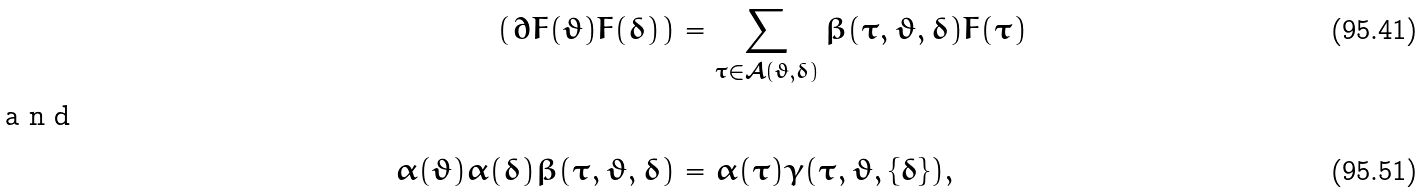Convert formula to latex. <formula><loc_0><loc_0><loc_500><loc_500>\left ( \partial F ( \vartheta ) F ( \delta ) \right ) & = \sum _ { \tau \in \mathcal { A } ( \vartheta , \delta ) } \beta ( \tau , \vartheta , \delta ) F ( \tau ) \\ \intertext { a n d } \alpha ( \vartheta ) \alpha ( \delta ) \beta ( \tau , \vartheta , \delta ) & = \alpha ( \tau ) \gamma ( \tau , \vartheta , \{ \delta \} ) ,</formula> 